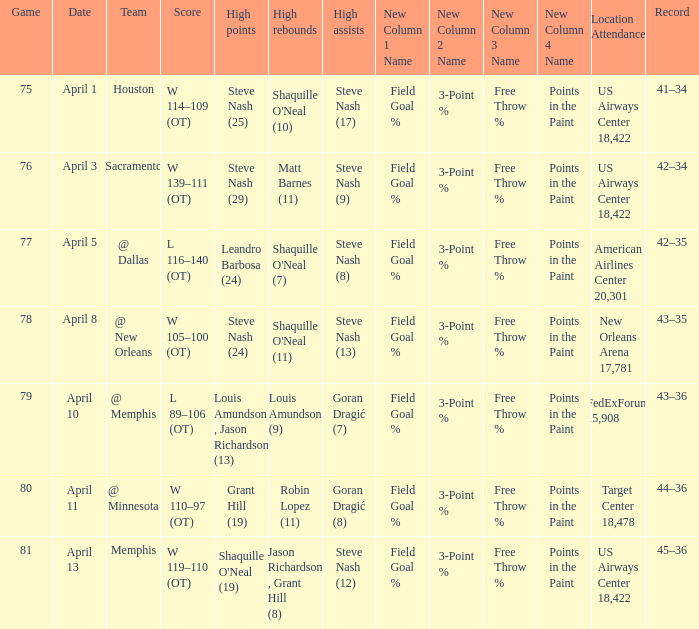Steve Nash (24) got high points for how many teams? 1.0. 